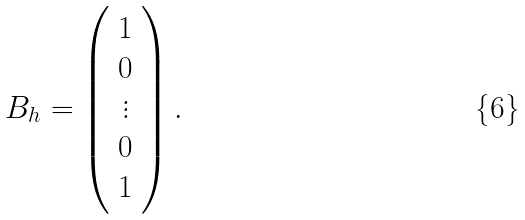Convert formula to latex. <formula><loc_0><loc_0><loc_500><loc_500>B _ { h } = \left ( \begin{array} { c c c } 1 \\ 0 \\ \vdots \\ 0 \\ 1 \end{array} \right ) .</formula> 